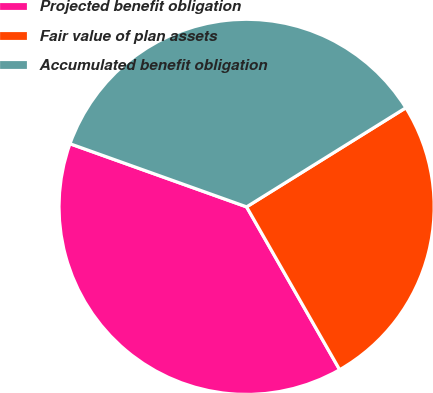<chart> <loc_0><loc_0><loc_500><loc_500><pie_chart><fcel>Projected benefit obligation<fcel>Fair value of plan assets<fcel>Accumulated benefit obligation<nl><fcel>38.73%<fcel>25.6%<fcel>35.68%<nl></chart> 